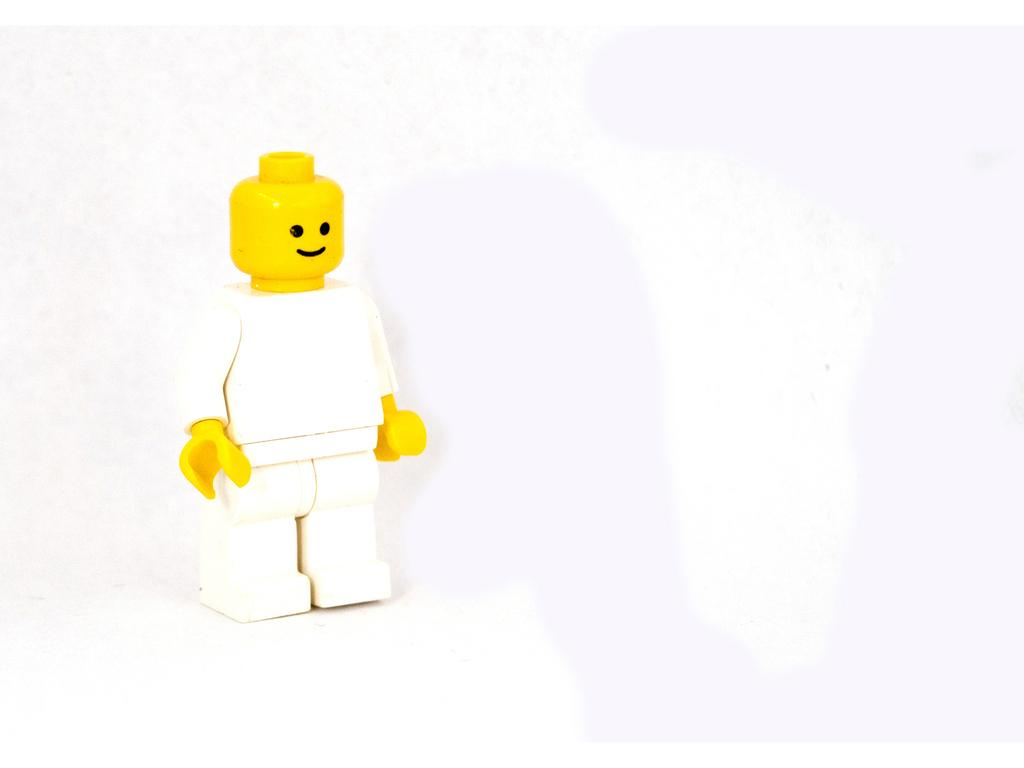What object is present in the image? There is a toy in the image. What colors can be seen on the toy? The toy has white, yellow, and black colors. What is the color of the background in the image? The background of the image is black. Can you tell me how many books are stacked on the grass in the image? There is no grass or books present in the image; it features a toy with white, yellow, and black colors against a black background. 